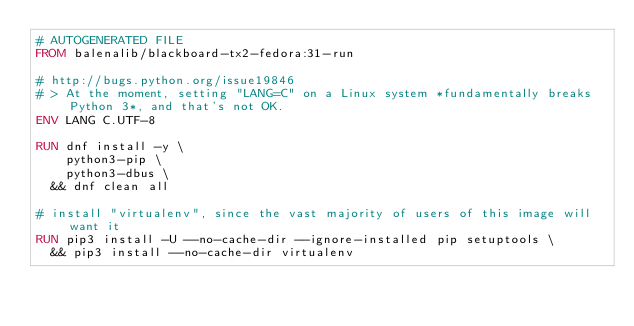<code> <loc_0><loc_0><loc_500><loc_500><_Dockerfile_># AUTOGENERATED FILE
FROM balenalib/blackboard-tx2-fedora:31-run

# http://bugs.python.org/issue19846
# > At the moment, setting "LANG=C" on a Linux system *fundamentally breaks Python 3*, and that's not OK.
ENV LANG C.UTF-8

RUN dnf install -y \
		python3-pip \
		python3-dbus \
	&& dnf clean all

# install "virtualenv", since the vast majority of users of this image will want it
RUN pip3 install -U --no-cache-dir --ignore-installed pip setuptools \
	&& pip3 install --no-cache-dir virtualenv
</code> 